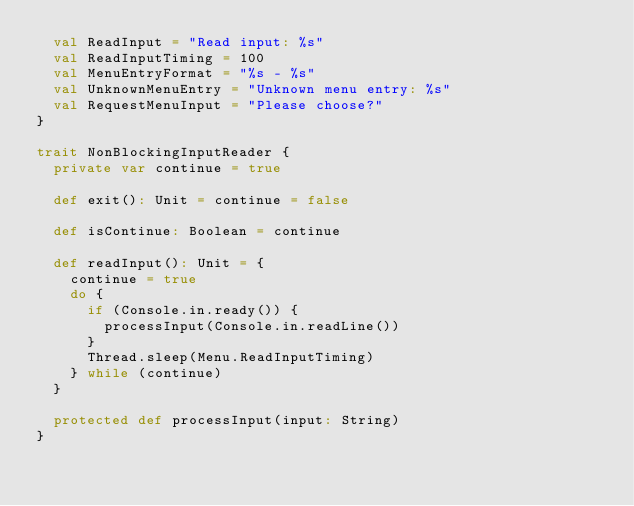<code> <loc_0><loc_0><loc_500><loc_500><_Scala_>  val ReadInput = "Read input: %s"
  val ReadInputTiming = 100
  val MenuEntryFormat = "%s - %s"
  val UnknownMenuEntry = "Unknown menu entry: %s"
  val RequestMenuInput = "Please choose?"
}

trait NonBlockingInputReader {
  private var continue = true

  def exit(): Unit = continue = false

  def isContinue: Boolean = continue

  def readInput(): Unit = {
    continue = true
    do {
      if (Console.in.ready()) {
        processInput(Console.in.readLine())
      }
      Thread.sleep(Menu.ReadInputTiming)
    } while (continue)
  }

  protected def processInput(input: String)
}</code> 